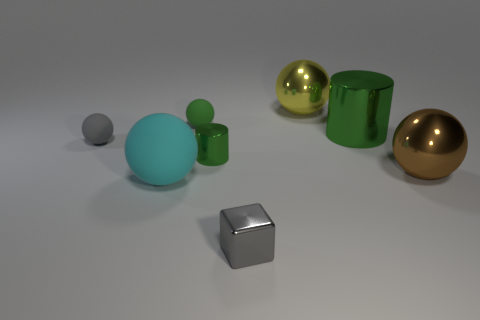What is the cyan thing made of?
Your answer should be very brief. Rubber. There is a rubber sphere that is to the right of the cyan matte object; what is its size?
Provide a short and direct response. Small. How many green metal things are to the left of the small object in front of the cyan sphere?
Your answer should be very brief. 1. There is a green thing on the right side of the small cube; does it have the same shape as the gray object behind the gray block?
Offer a very short reply. No. What number of balls are left of the yellow ball and behind the large green shiny thing?
Provide a succinct answer. 1. Are there any other big spheres that have the same color as the large rubber ball?
Make the answer very short. No. What is the shape of the shiny thing that is the same size as the cube?
Provide a succinct answer. Cylinder. There is a gray matte thing; are there any green metallic cylinders in front of it?
Offer a terse response. Yes. Is the thing that is in front of the big cyan ball made of the same material as the tiny gray object behind the big matte ball?
Offer a terse response. No. How many brown metal things are the same size as the gray ball?
Make the answer very short. 0. 